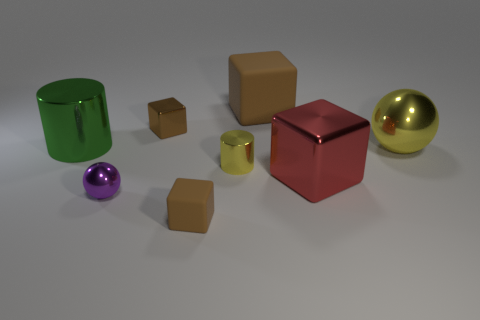Does the large green cylinder have the same material as the tiny cylinder?
Ensure brevity in your answer.  Yes. There is a big brown matte object that is right of the tiny matte thing; how many shiny objects are to the right of it?
Provide a short and direct response. 2. Is the purple metallic thing the same size as the yellow cylinder?
Your answer should be very brief. Yes. How many small cylinders have the same material as the big ball?
Give a very brief answer. 1. The purple metallic object that is the same shape as the large yellow metal thing is what size?
Offer a very short reply. Small. Do the big metallic thing that is on the left side of the large red object and the tiny matte object have the same shape?
Your response must be concise. No. The small shiny object that is on the left side of the tiny brown thing that is behind the big yellow metallic ball is what shape?
Provide a short and direct response. Sphere. Is there anything else that is the same shape as the large red metal thing?
Your response must be concise. Yes. There is a large metallic object that is the same shape as the small purple thing; what color is it?
Your response must be concise. Yellow. There is a large ball; does it have the same color as the big block to the left of the red metallic object?
Your answer should be compact. No. 